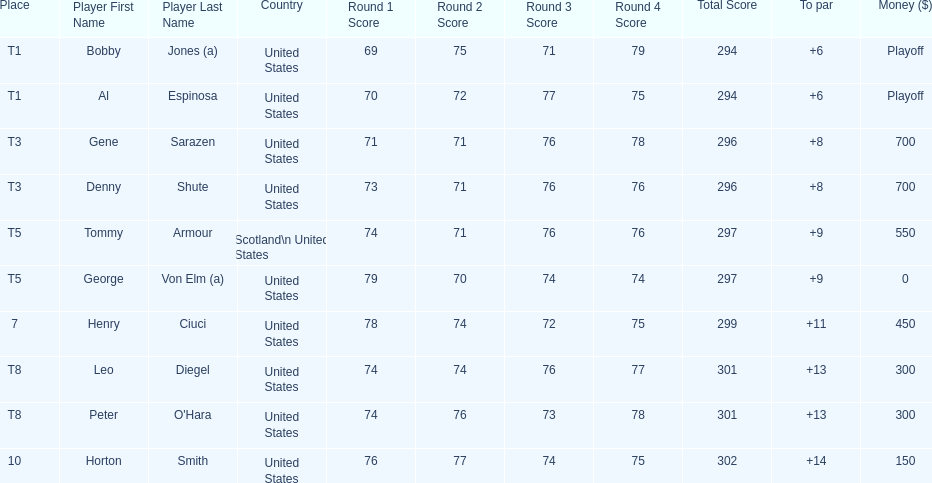Which two players tied for first place? Bobby Jones (a), Al Espinosa. 